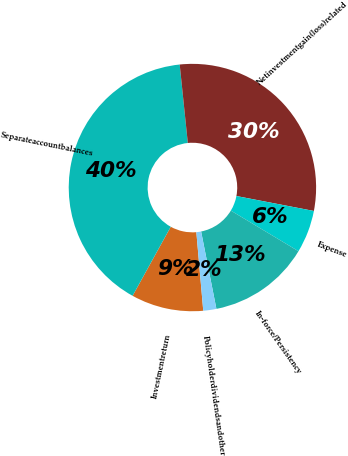<chart> <loc_0><loc_0><loc_500><loc_500><pie_chart><fcel>Investmentreturn<fcel>Separateaccountbalances<fcel>Netinvestmentgain(loss)related<fcel>Expense<fcel>In-force/Persistency<fcel>Policyholderdividendsandother<nl><fcel>9.43%<fcel>40.32%<fcel>29.67%<fcel>5.57%<fcel>13.29%<fcel>1.71%<nl></chart> 